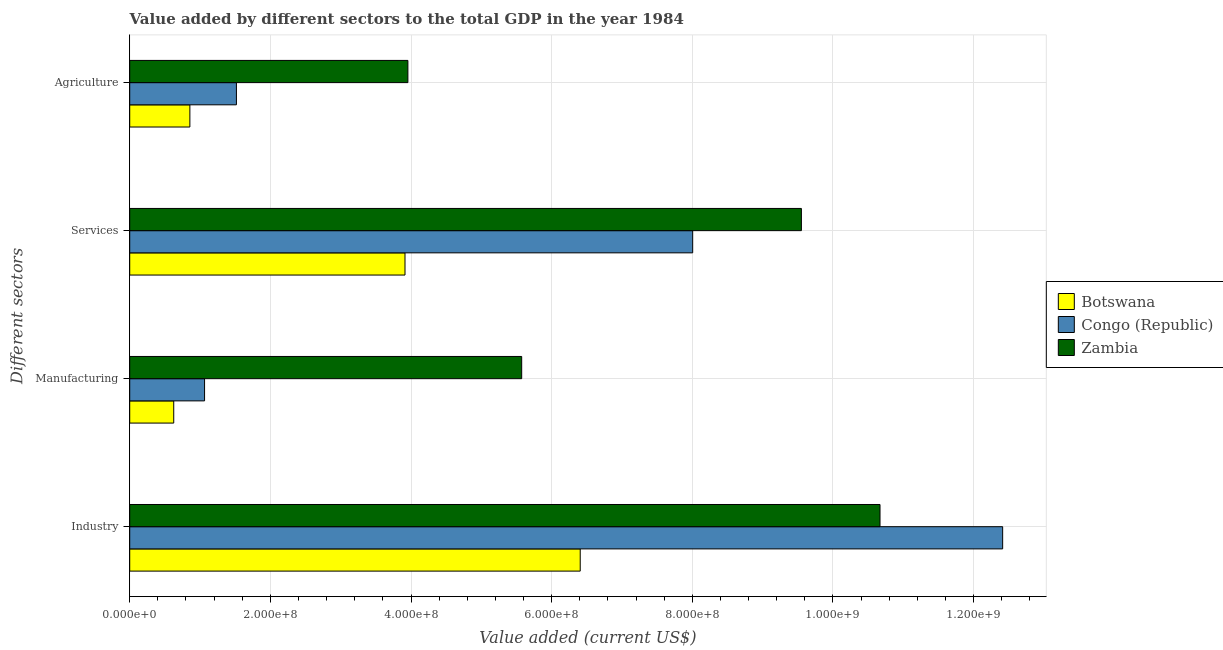How many different coloured bars are there?
Provide a short and direct response. 3. How many groups of bars are there?
Provide a short and direct response. 4. Are the number of bars on each tick of the Y-axis equal?
Make the answer very short. Yes. How many bars are there on the 1st tick from the top?
Make the answer very short. 3. What is the label of the 4th group of bars from the top?
Give a very brief answer. Industry. What is the value added by industrial sector in Zambia?
Your answer should be very brief. 1.07e+09. Across all countries, what is the maximum value added by industrial sector?
Provide a succinct answer. 1.24e+09. Across all countries, what is the minimum value added by manufacturing sector?
Your response must be concise. 6.26e+07. In which country was the value added by manufacturing sector maximum?
Provide a short and direct response. Zambia. In which country was the value added by industrial sector minimum?
Provide a short and direct response. Botswana. What is the total value added by manufacturing sector in the graph?
Keep it short and to the point. 7.26e+08. What is the difference between the value added by services sector in Botswana and that in Zambia?
Keep it short and to the point. -5.64e+08. What is the difference between the value added by manufacturing sector in Congo (Republic) and the value added by services sector in Zambia?
Offer a terse response. -8.49e+08. What is the average value added by agricultural sector per country?
Keep it short and to the point. 2.11e+08. What is the difference between the value added by agricultural sector and value added by services sector in Congo (Republic)?
Provide a succinct answer. -6.49e+08. In how many countries, is the value added by agricultural sector greater than 1200000000 US$?
Your answer should be compact. 0. What is the ratio of the value added by industrial sector in Botswana to that in Zambia?
Offer a very short reply. 0.6. Is the value added by manufacturing sector in Congo (Republic) less than that in Zambia?
Your response must be concise. Yes. Is the difference between the value added by agricultural sector in Congo (Republic) and Botswana greater than the difference between the value added by services sector in Congo (Republic) and Botswana?
Give a very brief answer. No. What is the difference between the highest and the second highest value added by agricultural sector?
Provide a succinct answer. 2.44e+08. What is the difference between the highest and the lowest value added by agricultural sector?
Provide a short and direct response. 3.10e+08. In how many countries, is the value added by services sector greater than the average value added by services sector taken over all countries?
Your answer should be very brief. 2. What does the 3rd bar from the top in Industry represents?
Give a very brief answer. Botswana. What does the 3rd bar from the bottom in Services represents?
Provide a succinct answer. Zambia. Is it the case that in every country, the sum of the value added by industrial sector and value added by manufacturing sector is greater than the value added by services sector?
Your response must be concise. Yes. How many bars are there?
Ensure brevity in your answer.  12. What is the difference between two consecutive major ticks on the X-axis?
Provide a short and direct response. 2.00e+08. Are the values on the major ticks of X-axis written in scientific E-notation?
Provide a succinct answer. Yes. What is the title of the graph?
Your answer should be compact. Value added by different sectors to the total GDP in the year 1984. What is the label or title of the X-axis?
Your answer should be compact. Value added (current US$). What is the label or title of the Y-axis?
Provide a short and direct response. Different sectors. What is the Value added (current US$) in Botswana in Industry?
Provide a short and direct response. 6.41e+08. What is the Value added (current US$) in Congo (Republic) in Industry?
Give a very brief answer. 1.24e+09. What is the Value added (current US$) in Zambia in Industry?
Ensure brevity in your answer.  1.07e+09. What is the Value added (current US$) of Botswana in Manufacturing?
Ensure brevity in your answer.  6.26e+07. What is the Value added (current US$) in Congo (Republic) in Manufacturing?
Ensure brevity in your answer.  1.06e+08. What is the Value added (current US$) of Zambia in Manufacturing?
Your answer should be compact. 5.57e+08. What is the Value added (current US$) in Botswana in Services?
Give a very brief answer. 3.91e+08. What is the Value added (current US$) of Congo (Republic) in Services?
Offer a very short reply. 8.01e+08. What is the Value added (current US$) of Zambia in Services?
Keep it short and to the point. 9.55e+08. What is the Value added (current US$) in Botswana in Agriculture?
Offer a very short reply. 8.55e+07. What is the Value added (current US$) of Congo (Republic) in Agriculture?
Offer a terse response. 1.52e+08. What is the Value added (current US$) in Zambia in Agriculture?
Offer a terse response. 3.96e+08. Across all Different sectors, what is the maximum Value added (current US$) in Botswana?
Provide a succinct answer. 6.41e+08. Across all Different sectors, what is the maximum Value added (current US$) in Congo (Republic)?
Provide a succinct answer. 1.24e+09. Across all Different sectors, what is the maximum Value added (current US$) in Zambia?
Give a very brief answer. 1.07e+09. Across all Different sectors, what is the minimum Value added (current US$) of Botswana?
Your answer should be compact. 6.26e+07. Across all Different sectors, what is the minimum Value added (current US$) in Congo (Republic)?
Provide a succinct answer. 1.06e+08. Across all Different sectors, what is the minimum Value added (current US$) of Zambia?
Your answer should be very brief. 3.96e+08. What is the total Value added (current US$) of Botswana in the graph?
Your answer should be compact. 1.18e+09. What is the total Value added (current US$) of Congo (Republic) in the graph?
Provide a short and direct response. 2.30e+09. What is the total Value added (current US$) of Zambia in the graph?
Offer a very short reply. 2.97e+09. What is the difference between the Value added (current US$) of Botswana in Industry and that in Manufacturing?
Offer a terse response. 5.78e+08. What is the difference between the Value added (current US$) of Congo (Republic) in Industry and that in Manufacturing?
Provide a short and direct response. 1.13e+09. What is the difference between the Value added (current US$) in Zambia in Industry and that in Manufacturing?
Your response must be concise. 5.10e+08. What is the difference between the Value added (current US$) of Botswana in Industry and that in Services?
Your answer should be very brief. 2.49e+08. What is the difference between the Value added (current US$) in Congo (Republic) in Industry and that in Services?
Your response must be concise. 4.41e+08. What is the difference between the Value added (current US$) in Zambia in Industry and that in Services?
Ensure brevity in your answer.  1.12e+08. What is the difference between the Value added (current US$) in Botswana in Industry and that in Agriculture?
Offer a very short reply. 5.55e+08. What is the difference between the Value added (current US$) in Congo (Republic) in Industry and that in Agriculture?
Make the answer very short. 1.09e+09. What is the difference between the Value added (current US$) in Zambia in Industry and that in Agriculture?
Provide a succinct answer. 6.71e+08. What is the difference between the Value added (current US$) of Botswana in Manufacturing and that in Services?
Ensure brevity in your answer.  -3.29e+08. What is the difference between the Value added (current US$) in Congo (Republic) in Manufacturing and that in Services?
Provide a short and direct response. -6.94e+08. What is the difference between the Value added (current US$) in Zambia in Manufacturing and that in Services?
Provide a succinct answer. -3.98e+08. What is the difference between the Value added (current US$) in Botswana in Manufacturing and that in Agriculture?
Offer a terse response. -2.30e+07. What is the difference between the Value added (current US$) of Congo (Republic) in Manufacturing and that in Agriculture?
Your answer should be compact. -4.53e+07. What is the difference between the Value added (current US$) in Zambia in Manufacturing and that in Agriculture?
Provide a succinct answer. 1.62e+08. What is the difference between the Value added (current US$) in Botswana in Services and that in Agriculture?
Provide a succinct answer. 3.06e+08. What is the difference between the Value added (current US$) of Congo (Republic) in Services and that in Agriculture?
Give a very brief answer. 6.49e+08. What is the difference between the Value added (current US$) in Zambia in Services and that in Agriculture?
Your answer should be compact. 5.60e+08. What is the difference between the Value added (current US$) of Botswana in Industry and the Value added (current US$) of Congo (Republic) in Manufacturing?
Make the answer very short. 5.34e+08. What is the difference between the Value added (current US$) of Botswana in Industry and the Value added (current US$) of Zambia in Manufacturing?
Offer a terse response. 8.32e+07. What is the difference between the Value added (current US$) of Congo (Republic) in Industry and the Value added (current US$) of Zambia in Manufacturing?
Your response must be concise. 6.84e+08. What is the difference between the Value added (current US$) of Botswana in Industry and the Value added (current US$) of Congo (Republic) in Services?
Offer a terse response. -1.60e+08. What is the difference between the Value added (current US$) in Botswana in Industry and the Value added (current US$) in Zambia in Services?
Your response must be concise. -3.15e+08. What is the difference between the Value added (current US$) in Congo (Republic) in Industry and the Value added (current US$) in Zambia in Services?
Your answer should be very brief. 2.86e+08. What is the difference between the Value added (current US$) in Botswana in Industry and the Value added (current US$) in Congo (Republic) in Agriculture?
Your answer should be compact. 4.89e+08. What is the difference between the Value added (current US$) of Botswana in Industry and the Value added (current US$) of Zambia in Agriculture?
Give a very brief answer. 2.45e+08. What is the difference between the Value added (current US$) of Congo (Republic) in Industry and the Value added (current US$) of Zambia in Agriculture?
Ensure brevity in your answer.  8.46e+08. What is the difference between the Value added (current US$) of Botswana in Manufacturing and the Value added (current US$) of Congo (Republic) in Services?
Give a very brief answer. -7.38e+08. What is the difference between the Value added (current US$) in Botswana in Manufacturing and the Value added (current US$) in Zambia in Services?
Your response must be concise. -8.93e+08. What is the difference between the Value added (current US$) in Congo (Republic) in Manufacturing and the Value added (current US$) in Zambia in Services?
Provide a succinct answer. -8.49e+08. What is the difference between the Value added (current US$) of Botswana in Manufacturing and the Value added (current US$) of Congo (Republic) in Agriculture?
Provide a succinct answer. -8.92e+07. What is the difference between the Value added (current US$) in Botswana in Manufacturing and the Value added (current US$) in Zambia in Agriculture?
Your response must be concise. -3.33e+08. What is the difference between the Value added (current US$) of Congo (Republic) in Manufacturing and the Value added (current US$) of Zambia in Agriculture?
Provide a short and direct response. -2.89e+08. What is the difference between the Value added (current US$) of Botswana in Services and the Value added (current US$) of Congo (Republic) in Agriculture?
Keep it short and to the point. 2.40e+08. What is the difference between the Value added (current US$) in Botswana in Services and the Value added (current US$) in Zambia in Agriculture?
Your answer should be very brief. -4.09e+06. What is the difference between the Value added (current US$) of Congo (Republic) in Services and the Value added (current US$) of Zambia in Agriculture?
Your answer should be compact. 4.05e+08. What is the average Value added (current US$) in Botswana per Different sectors?
Give a very brief answer. 2.95e+08. What is the average Value added (current US$) of Congo (Republic) per Different sectors?
Provide a short and direct response. 5.75e+08. What is the average Value added (current US$) in Zambia per Different sectors?
Ensure brevity in your answer.  7.44e+08. What is the difference between the Value added (current US$) in Botswana and Value added (current US$) in Congo (Republic) in Industry?
Provide a short and direct response. -6.01e+08. What is the difference between the Value added (current US$) of Botswana and Value added (current US$) of Zambia in Industry?
Provide a short and direct response. -4.26e+08. What is the difference between the Value added (current US$) of Congo (Republic) and Value added (current US$) of Zambia in Industry?
Make the answer very short. 1.74e+08. What is the difference between the Value added (current US$) in Botswana and Value added (current US$) in Congo (Republic) in Manufacturing?
Ensure brevity in your answer.  -4.38e+07. What is the difference between the Value added (current US$) in Botswana and Value added (current US$) in Zambia in Manufacturing?
Offer a terse response. -4.95e+08. What is the difference between the Value added (current US$) of Congo (Republic) and Value added (current US$) of Zambia in Manufacturing?
Keep it short and to the point. -4.51e+08. What is the difference between the Value added (current US$) of Botswana and Value added (current US$) of Congo (Republic) in Services?
Give a very brief answer. -4.09e+08. What is the difference between the Value added (current US$) in Botswana and Value added (current US$) in Zambia in Services?
Make the answer very short. -5.64e+08. What is the difference between the Value added (current US$) of Congo (Republic) and Value added (current US$) of Zambia in Services?
Make the answer very short. -1.55e+08. What is the difference between the Value added (current US$) in Botswana and Value added (current US$) in Congo (Republic) in Agriculture?
Ensure brevity in your answer.  -6.62e+07. What is the difference between the Value added (current US$) of Botswana and Value added (current US$) of Zambia in Agriculture?
Give a very brief answer. -3.10e+08. What is the difference between the Value added (current US$) in Congo (Republic) and Value added (current US$) in Zambia in Agriculture?
Offer a very short reply. -2.44e+08. What is the ratio of the Value added (current US$) in Botswana in Industry to that in Manufacturing?
Your response must be concise. 10.24. What is the ratio of the Value added (current US$) in Congo (Republic) in Industry to that in Manufacturing?
Your response must be concise. 11.66. What is the ratio of the Value added (current US$) in Zambia in Industry to that in Manufacturing?
Provide a succinct answer. 1.91. What is the ratio of the Value added (current US$) in Botswana in Industry to that in Services?
Offer a terse response. 1.64. What is the ratio of the Value added (current US$) of Congo (Republic) in Industry to that in Services?
Your answer should be compact. 1.55. What is the ratio of the Value added (current US$) in Zambia in Industry to that in Services?
Make the answer very short. 1.12. What is the ratio of the Value added (current US$) in Botswana in Industry to that in Agriculture?
Offer a terse response. 7.49. What is the ratio of the Value added (current US$) of Congo (Republic) in Industry to that in Agriculture?
Make the answer very short. 8.18. What is the ratio of the Value added (current US$) in Zambia in Industry to that in Agriculture?
Give a very brief answer. 2.7. What is the ratio of the Value added (current US$) in Botswana in Manufacturing to that in Services?
Your answer should be compact. 0.16. What is the ratio of the Value added (current US$) in Congo (Republic) in Manufacturing to that in Services?
Your answer should be very brief. 0.13. What is the ratio of the Value added (current US$) of Zambia in Manufacturing to that in Services?
Ensure brevity in your answer.  0.58. What is the ratio of the Value added (current US$) of Botswana in Manufacturing to that in Agriculture?
Ensure brevity in your answer.  0.73. What is the ratio of the Value added (current US$) of Congo (Republic) in Manufacturing to that in Agriculture?
Your answer should be compact. 0.7. What is the ratio of the Value added (current US$) in Zambia in Manufacturing to that in Agriculture?
Keep it short and to the point. 1.41. What is the ratio of the Value added (current US$) of Botswana in Services to that in Agriculture?
Your answer should be very brief. 4.58. What is the ratio of the Value added (current US$) in Congo (Republic) in Services to that in Agriculture?
Give a very brief answer. 5.28. What is the ratio of the Value added (current US$) in Zambia in Services to that in Agriculture?
Your answer should be very brief. 2.41. What is the difference between the highest and the second highest Value added (current US$) in Botswana?
Make the answer very short. 2.49e+08. What is the difference between the highest and the second highest Value added (current US$) in Congo (Republic)?
Offer a terse response. 4.41e+08. What is the difference between the highest and the second highest Value added (current US$) in Zambia?
Offer a terse response. 1.12e+08. What is the difference between the highest and the lowest Value added (current US$) of Botswana?
Offer a terse response. 5.78e+08. What is the difference between the highest and the lowest Value added (current US$) of Congo (Republic)?
Your response must be concise. 1.13e+09. What is the difference between the highest and the lowest Value added (current US$) in Zambia?
Make the answer very short. 6.71e+08. 